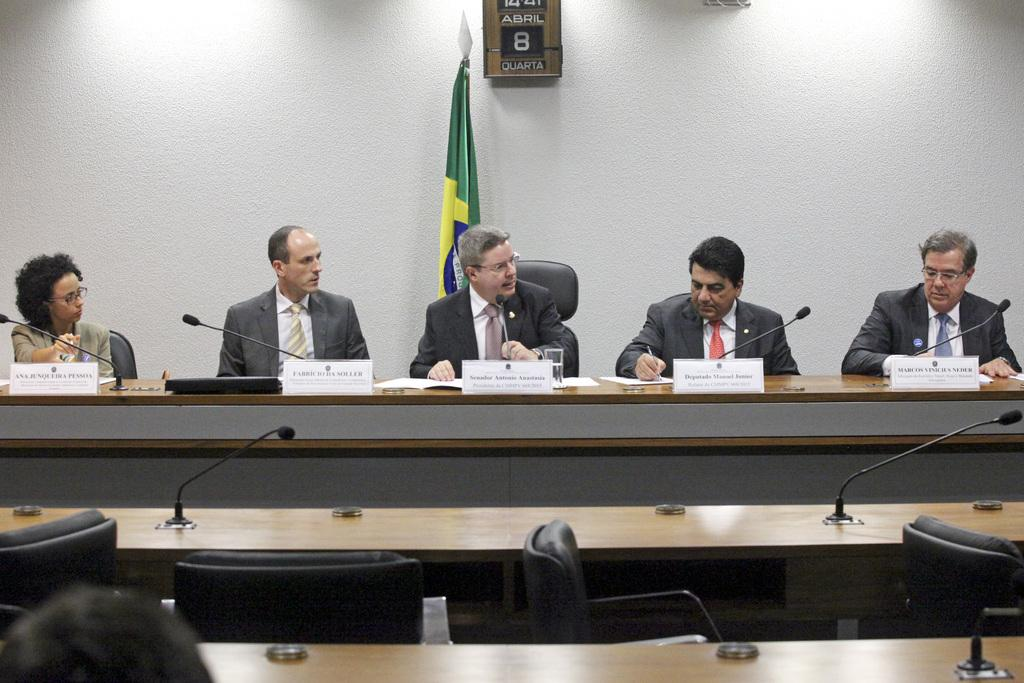How many people are sitting on the chair in the image? There are five persons sitting on a chair in the image. What is the person in the image doing with the microphone? The person is speaking on a microphone in the image. What can be seen in the background of the image? There is a flag in the background of the image. What type of fork is being used by the man in the image? There is no man or fork present in the image. What genre of fiction is being discussed by the person speaking on the microphone? The image does not provide information about the topic of discussion, so it cannot be determined if it is related to fiction. 